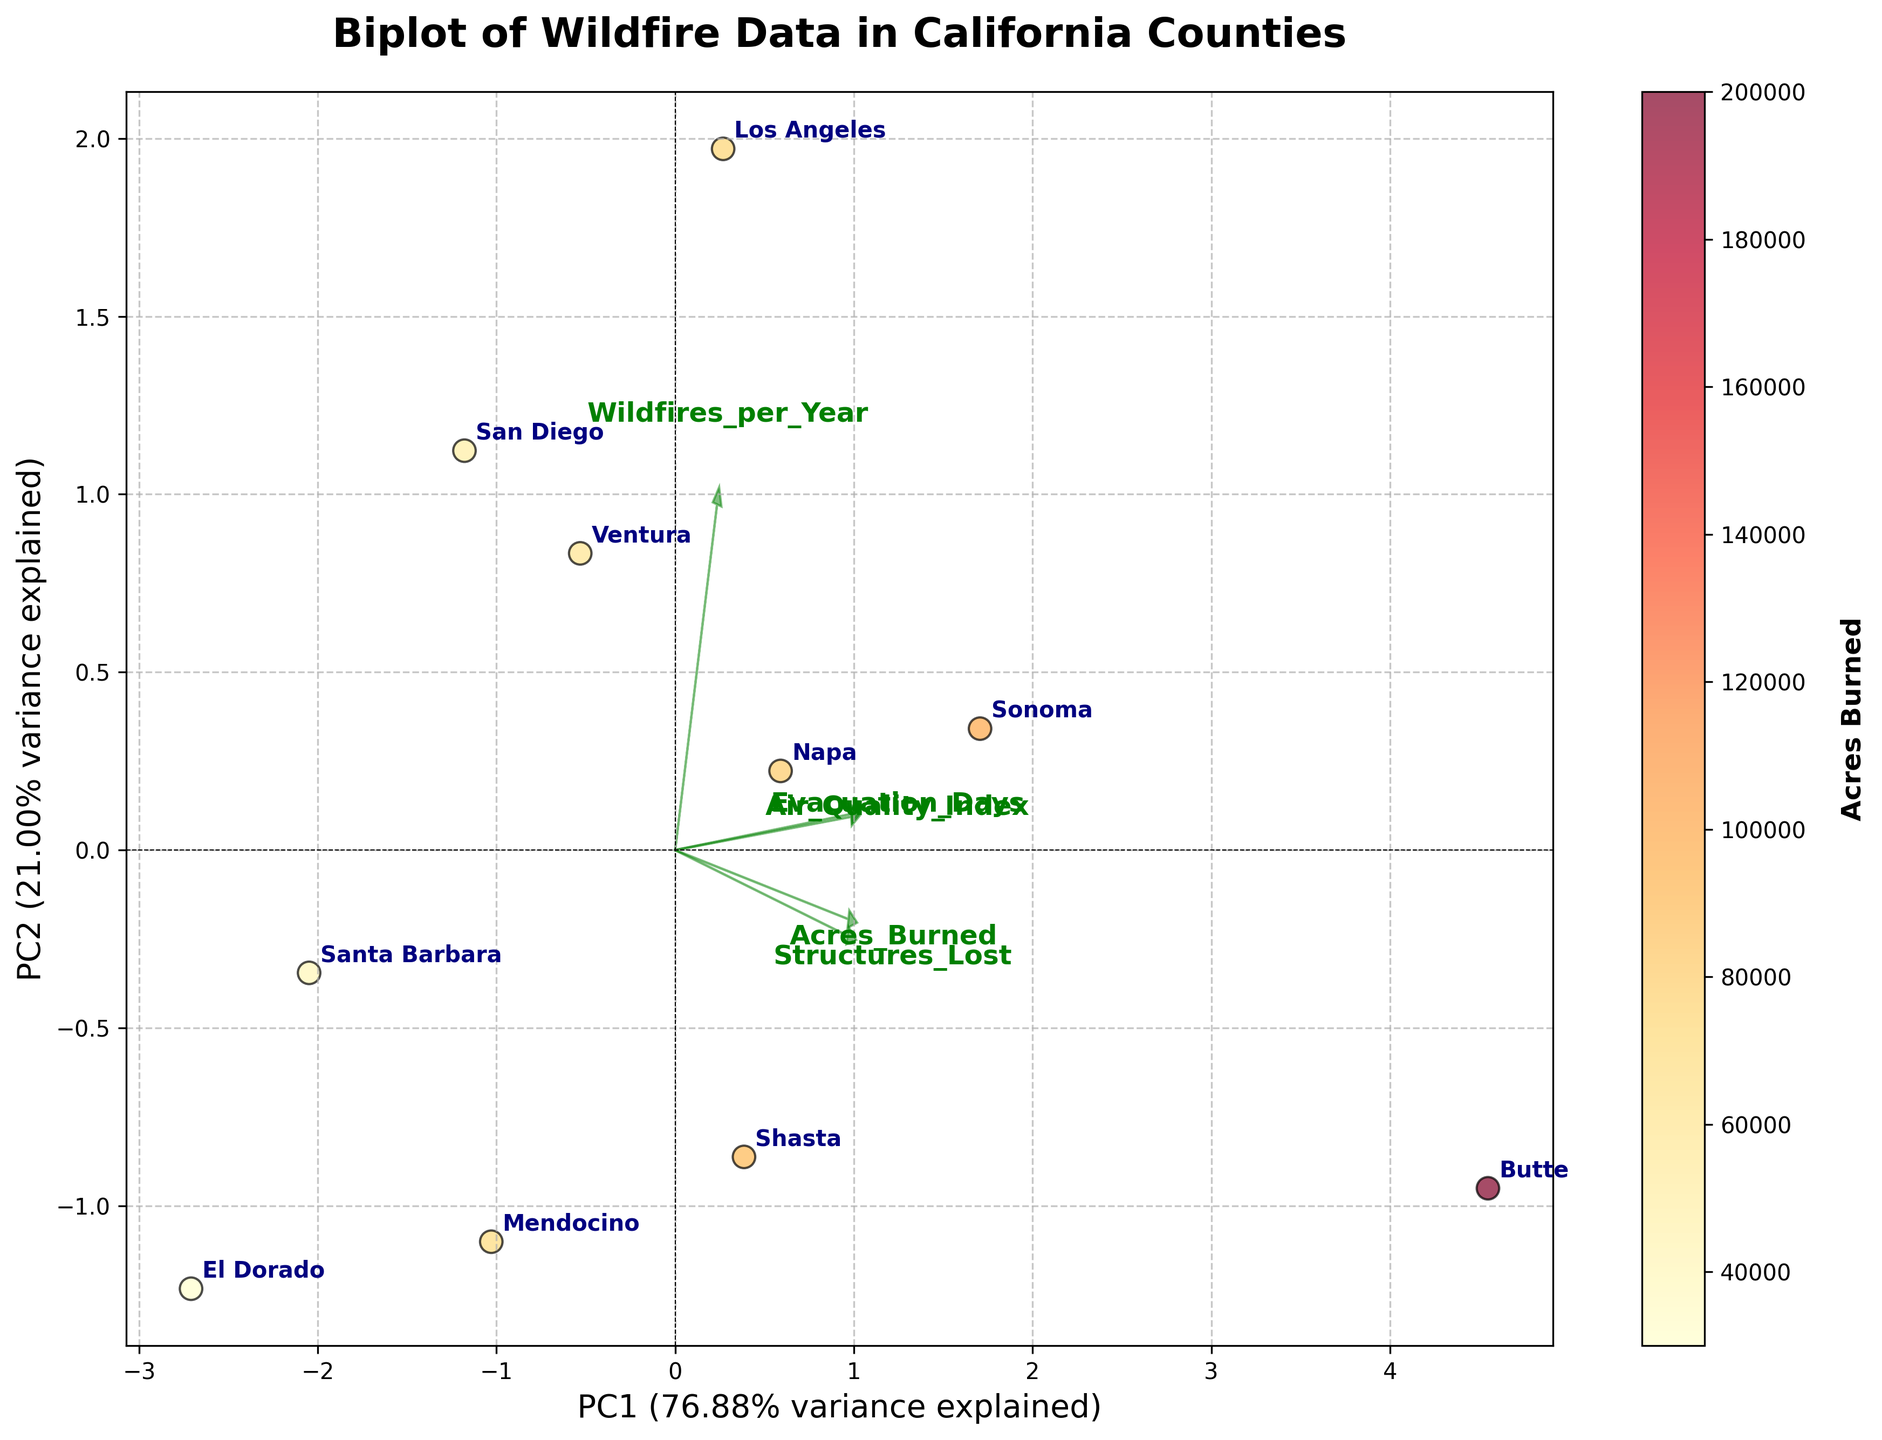What's the title of the figure? The title is written at the top of the figure.
Answer: Biplot of Wildfire Data in California Counties What does the color of the data points represent? The color of the data points is specified in the color bar on the right side of the figure, which states it represents "Acres Burned."
Answer: Acres Burned Which axis represents the first principal component (PC1)? The labels at the end of the x and y axes specify which principal component they represent. The x-axis is labeled with PC1.
Answer: x-axis What is the variance explained by PC1? The variance explained by PC1 is mentioned in the label of the x-axis as a percentage value.
Answer: 64% Which county has the highest number of wildfires per year? The county names are annotated near each data point. Counties farthest in the x or y direction generally represent higher values. Los Angeles is quite far out in the x direction, where the loadings for the wildfires per year are high.
Answer: Los Angeles Which California county has the highest air quality index? The green arrow labeled "Air Quality Index" points towards the counties with higher indices, with Butte being farthest in that direction.
Answer: Butte How many data points are there in the plot? Counting the number of annotated county names gives the total number of data points.
Answer: 10 Which county is positioned closest to the origin of the plot? Observing the position of data points relative to the origin both horizontally and vertically, El Dorado appears closest to the center.
Answer: El Dorado Which county has the most structures lost to wildfires? The data point closest to the direction of the arrow labeled "Structures_Lost," which points towards Sonoma and Butte, needs verification. Butte is farther in this direction.
Answer: Butte 